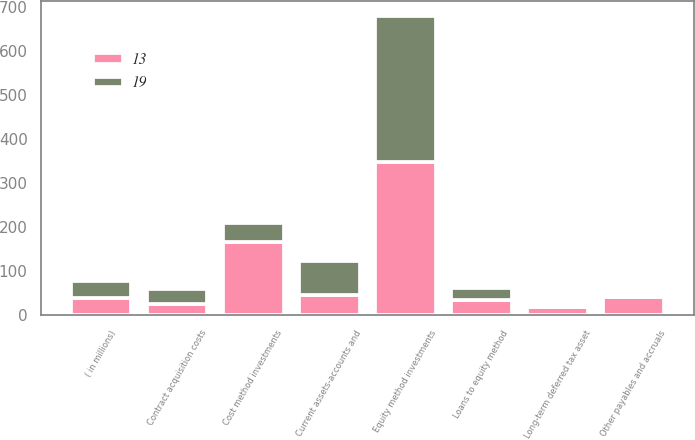Convert chart to OTSL. <chart><loc_0><loc_0><loc_500><loc_500><stacked_bar_chart><ecel><fcel>( in millions)<fcel>Current assets-accounts and<fcel>Contract acquisition costs<fcel>Cost method investments<fcel>Equity method investments<fcel>Loans to equity method<fcel>Long-term deferred tax asset<fcel>Other payables and accruals<nl><fcel>19<fcel>39.5<fcel>76<fcel>34<fcel>45<fcel>332<fcel>27<fcel>4<fcel>2<nl><fcel>13<fcel>39.5<fcel>47<fcel>26<fcel>166<fcel>349<fcel>36<fcel>19<fcel>43<nl></chart> 